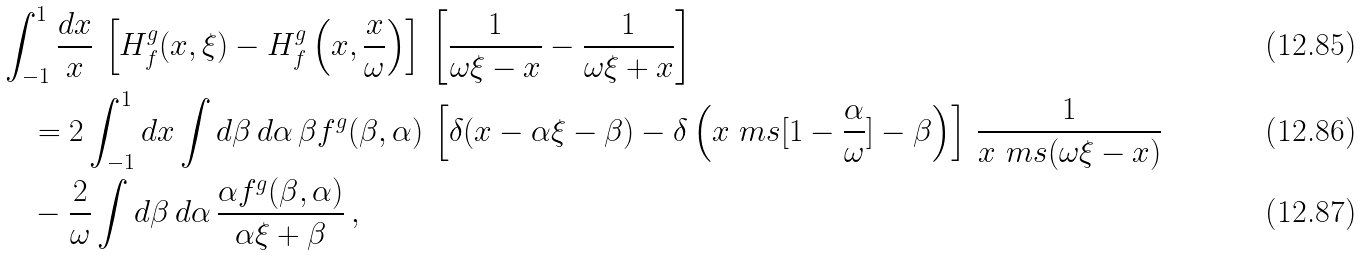<formula> <loc_0><loc_0><loc_500><loc_500>& \int _ { - 1 } ^ { 1 } \frac { d x } { x } \, \left [ H ^ { g } _ { f } ( x , \xi ) - H ^ { g } _ { f } \left ( x , \frac { x } { \omega } \right ) \right ] \, \left [ \frac { 1 } { \omega \xi - x } - \frac { 1 } { \omega \xi + x } \right ] \\ & \quad = 2 \int _ { - 1 } ^ { 1 } d x \int d \beta \, d \alpha \, \beta f ^ { g } ( \beta , \alpha ) \, \left [ \delta ( x - \alpha \xi - \beta ) - \delta \left ( x \ m s [ 1 - \frac { \alpha } { \omega } ] - \beta \right ) \right ] \, \frac { 1 } { x \ m s ( \omega \xi - x ) } \\ & \quad - \frac { 2 } { \omega } \int d \beta \, d \alpha \, \frac { \alpha f ^ { g } ( \beta , \alpha ) } { \alpha \xi + \beta } \, ,</formula> 